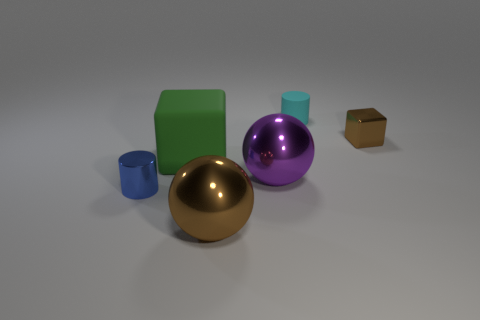There is a purple metallic sphere in front of the rubber thing that is to the right of the large green thing; what number of large spheres are in front of it?
Provide a short and direct response. 1. How many other things are there of the same material as the large green block?
Give a very brief answer. 1. There is a purple object that is the same size as the green block; what material is it?
Provide a succinct answer. Metal. Does the small metal object to the right of the brown ball have the same color as the big metal ball in front of the tiny metal cylinder?
Ensure brevity in your answer.  Yes. Is there another thing that has the same shape as the small brown metal object?
Keep it short and to the point. Yes. What shape is the other shiny object that is the same size as the purple thing?
Your answer should be very brief. Sphere. What number of shiny objects are the same color as the small metal cube?
Your answer should be compact. 1. What is the size of the rubber object behind the green matte object?
Offer a very short reply. Small. What number of cyan cylinders are the same size as the blue thing?
Provide a short and direct response. 1. The small object that is made of the same material as the large green block is what color?
Keep it short and to the point. Cyan. 